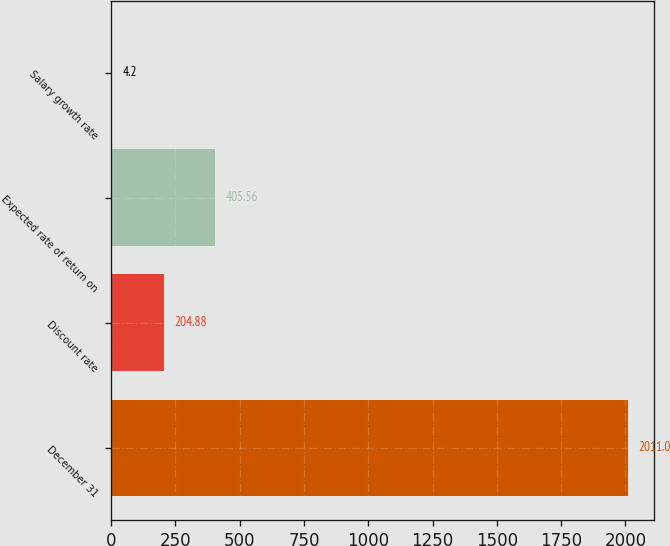Convert chart to OTSL. <chart><loc_0><loc_0><loc_500><loc_500><bar_chart><fcel>December 31<fcel>Discount rate<fcel>Expected rate of return on<fcel>Salary growth rate<nl><fcel>2011<fcel>204.88<fcel>405.56<fcel>4.2<nl></chart> 